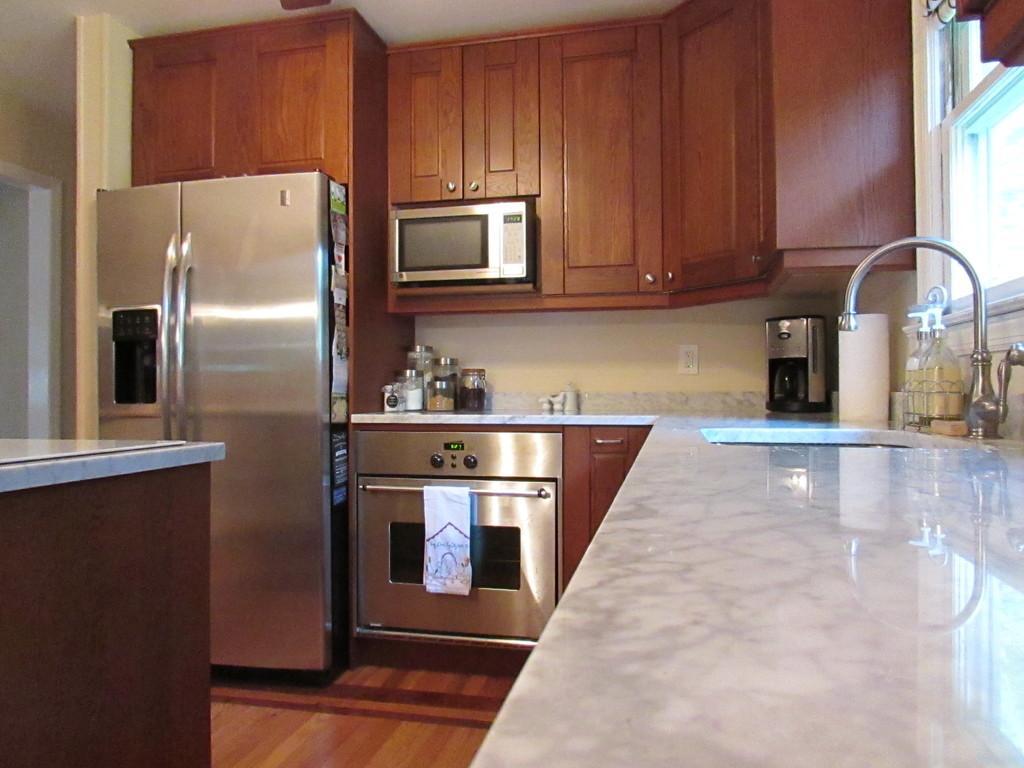Can you describe this image briefly? In this image we can see inside view of a kitchen, there is refrigerator, stove besides microwave oven, there is sink, coffee maker and some other items and bottles on surface, top of the image we can see cupboards, oven. 